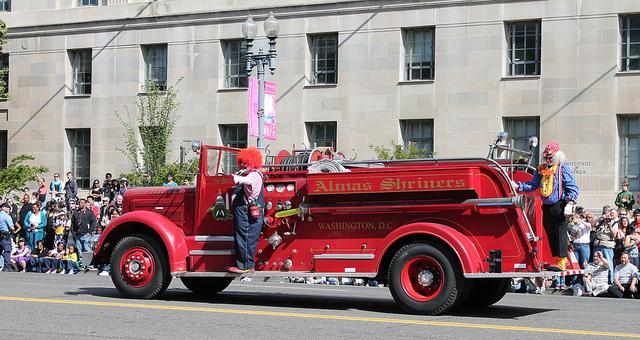What color is the truck?
Short answer required. Red. What is this truck?
Answer briefly. Fire truck. Is this an antique fire truck?
Write a very short answer. Yes. How many trucks can you see?
Write a very short answer. 1. What type of windows does the building have?
Keep it brief. Square. What company is advertised on the side of the truck?
Give a very brief answer. Almas shriners. What type of people are on the truck?
Give a very brief answer. Clowns. Are there any people in the scene?
Give a very brief answer. Yes. Where is the child standing?
Quick response, please. On sidewalk. What fire department is displayed on the sign?
Short answer required. Washington dc. 